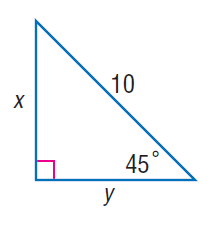Answer the mathemtical geometry problem and directly provide the correct option letter.
Question: Find x.
Choices: A: 5 B: 5 \sqrt { 2 } C: 10 D: 10 \sqrt { 2 } B 